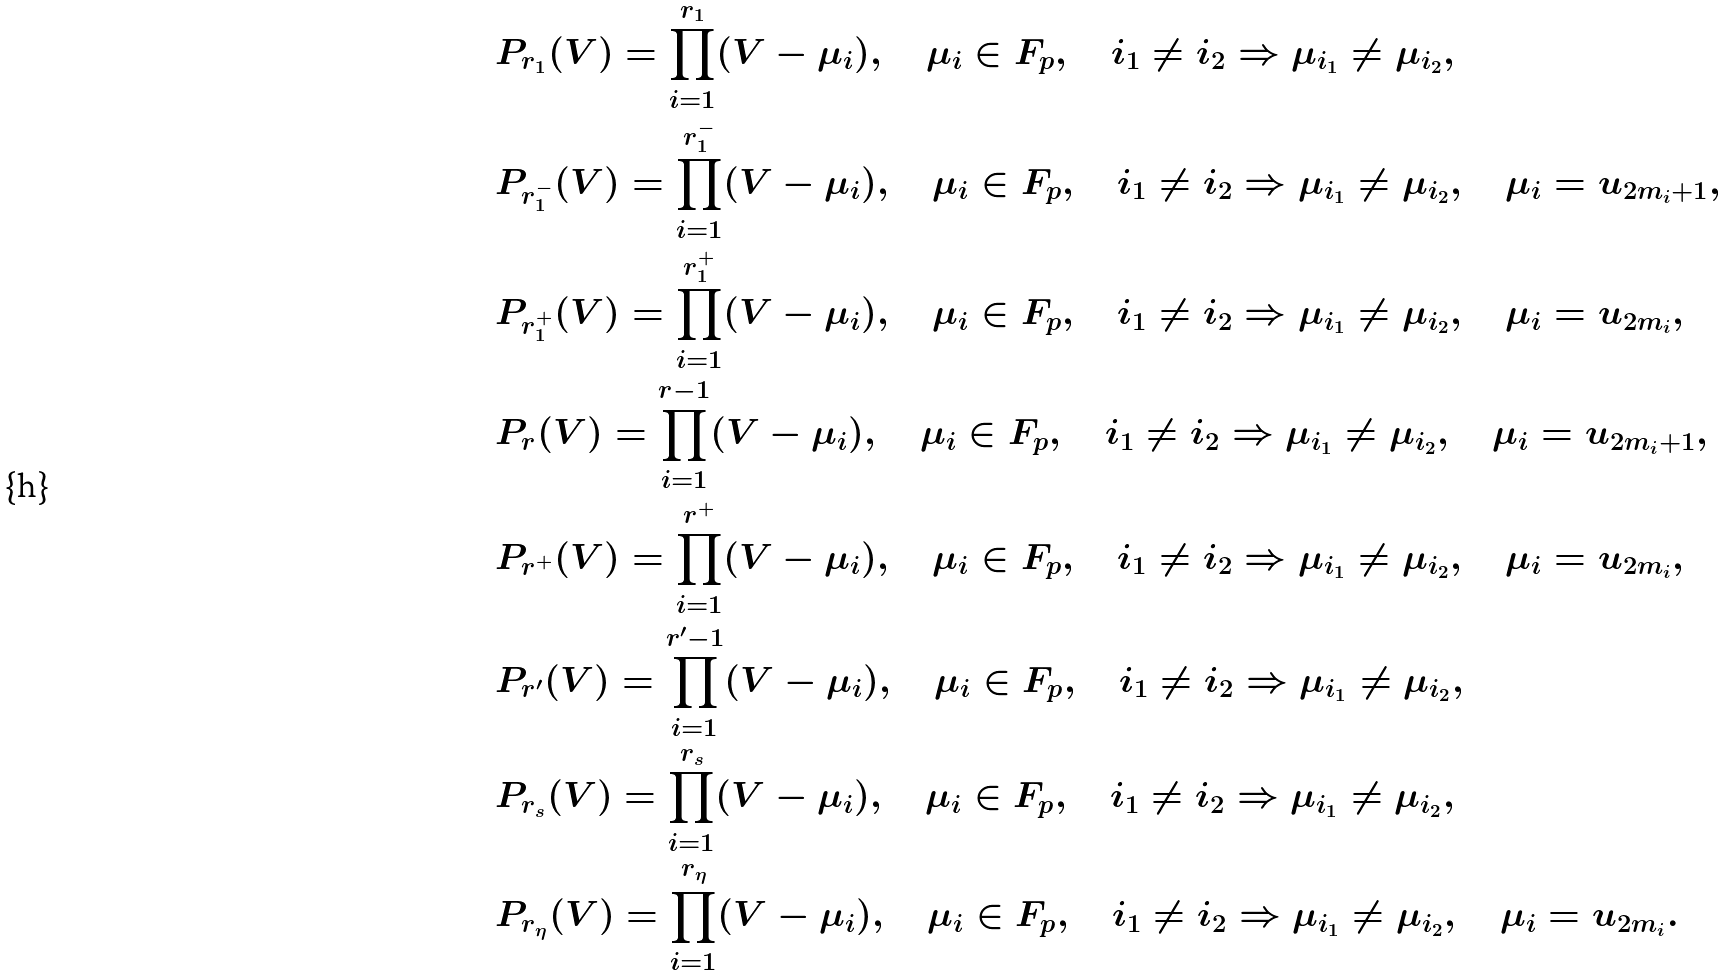<formula> <loc_0><loc_0><loc_500><loc_500>& P _ { r _ { 1 } } ( V ) = \prod _ { i = 1 } ^ { r _ { 1 } } ( V - \mu _ { i } ) , \quad \mu _ { i } \in { F } _ { p } , \quad i _ { 1 } \not = i _ { 2 } \Rightarrow \mu _ { i _ { 1 } } \not = \mu _ { i _ { 2 } } , \\ & P _ { r _ { 1 } ^ { - } } ( V ) = \prod _ { i = 1 } ^ { r _ { 1 } ^ { - } } ( V - \mu _ { i } ) , \quad \mu _ { i } \in { F } _ { p } , \quad i _ { 1 } \not = i _ { 2 } \Rightarrow \mu _ { i _ { 1 } } \not = \mu _ { i _ { 2 } } , \quad \mu _ { i } = u _ { 2 m _ { i } + 1 } , \\ & P _ { r _ { 1 } ^ { + } } ( V ) = \prod _ { i = 1 } ^ { r _ { 1 } ^ { + } } ( V - \mu _ { i } ) , \quad \mu _ { i } \in { F } _ { p } , \quad i _ { 1 } \not = i _ { 2 } \Rightarrow \mu _ { i _ { 1 } } \not = \mu _ { i _ { 2 } } , \quad \mu _ { i } = u _ { 2 m _ { i } } , \\ & P _ { r } ( V ) = \prod _ { i = 1 } ^ { r - 1 } ( V - \mu _ { i } ) , \quad \mu _ { i } \in { F } _ { p } , \quad i _ { 1 } \not = i _ { 2 } \Rightarrow \mu _ { i _ { 1 } } \not = \mu _ { i _ { 2 } } , \quad \mu _ { i } = u _ { 2 m _ { i } + 1 } , \\ & P _ { r ^ { + } } ( V ) = \prod _ { i = 1 } ^ { r ^ { + } } ( V - \mu _ { i } ) , \quad \mu _ { i } \in { F } _ { p } , \quad i _ { 1 } \not = i _ { 2 } \Rightarrow \mu _ { i _ { 1 } } \not = \mu _ { i _ { 2 } } , \quad \mu _ { i } = u _ { 2 m _ { i } } , \\ & P _ { r ^ { \prime } } ( V ) = \prod _ { i = 1 } ^ { r ^ { \prime } - 1 } ( V - \mu _ { i } ) , \quad \mu _ { i } \in { F } _ { p } , \quad i _ { 1 } \not = i _ { 2 } \Rightarrow \mu _ { i _ { 1 } } \not = \mu _ { i _ { 2 } } , \\ & P _ { r _ { s } } ( V ) = \prod _ { i = 1 } ^ { r _ { s } } ( V - \mu _ { i } ) , \quad \mu _ { i } \in { F } _ { p } , \quad i _ { 1 } \not = i _ { 2 } \Rightarrow \mu _ { i _ { 1 } } \not = \mu _ { i _ { 2 } } , \\ & P _ { r _ { \eta } } ( V ) = \prod _ { i = 1 } ^ { r _ { \eta } } ( V - \mu _ { i } ) , \quad \mu _ { i } \in { F } _ { p } , \quad i _ { 1 } \not = i _ { 2 } \Rightarrow \mu _ { i _ { 1 } } \not = \mu _ { i _ { 2 } } , \quad \mu _ { i } = u _ { 2 m _ { i } } .</formula> 